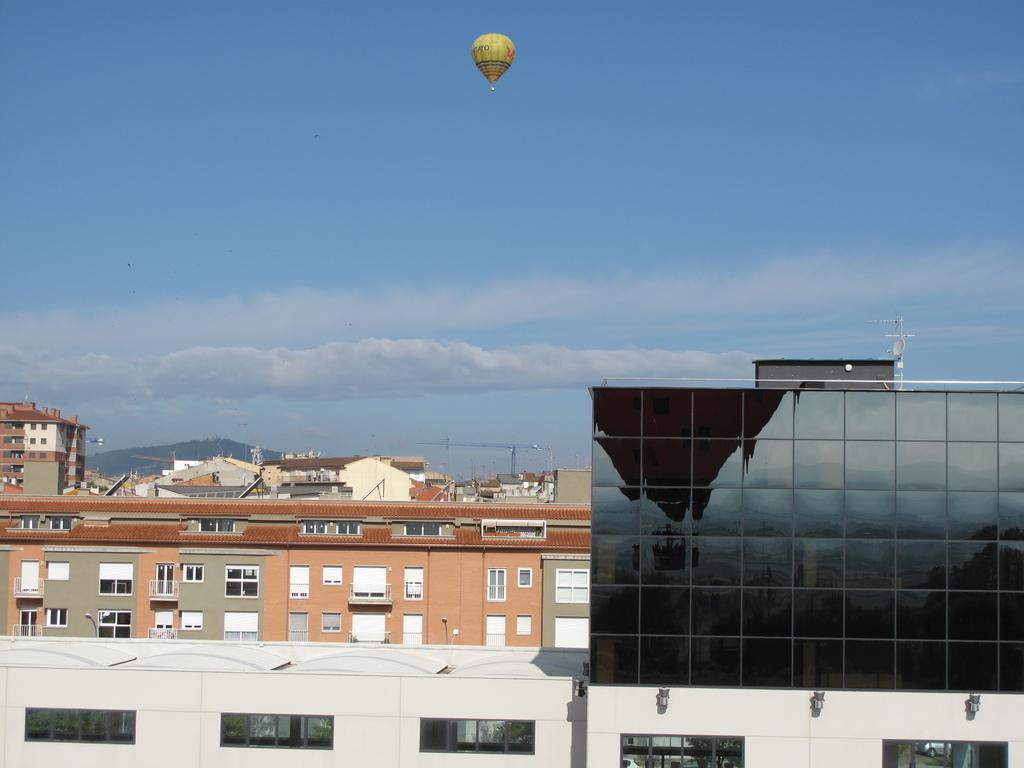How would you summarize this image in a sentence or two? In this image we can see buildings, windows. At the top of the image there is air balloon, sky and clouds. 